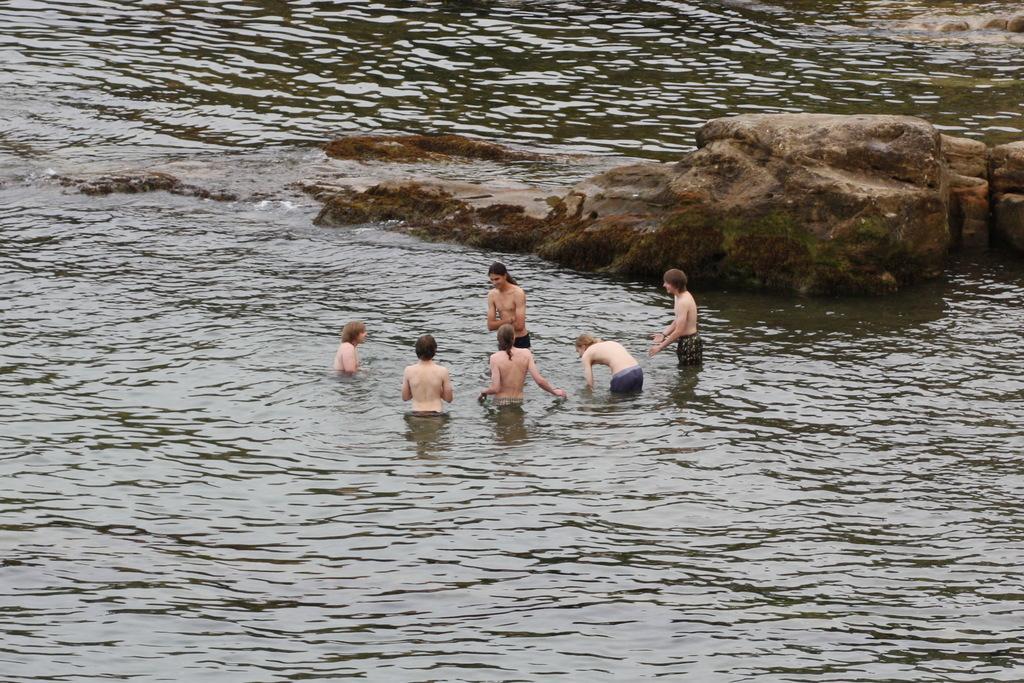How would you summarize this image in a sentence or two? In this image in the center there are persons standing in the water. In the background there are rocks and there is water. 